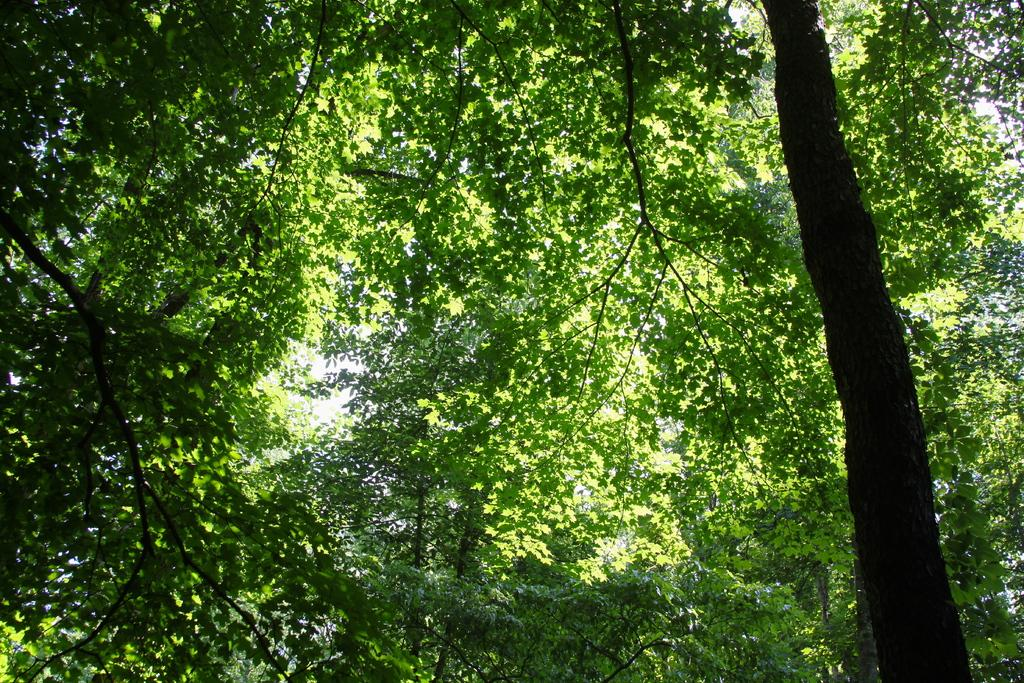What type of vegetation can be seen in the image? There are trees in the image. What part of the natural environment is visible in the image? The sky is visible in the background of the image. Can you see any cherries hanging from the trees in the image? There is no mention of cherries in the image, so we cannot determine if they are present or not. 